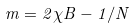<formula> <loc_0><loc_0><loc_500><loc_500>m = 2 \chi B - 1 / N</formula> 